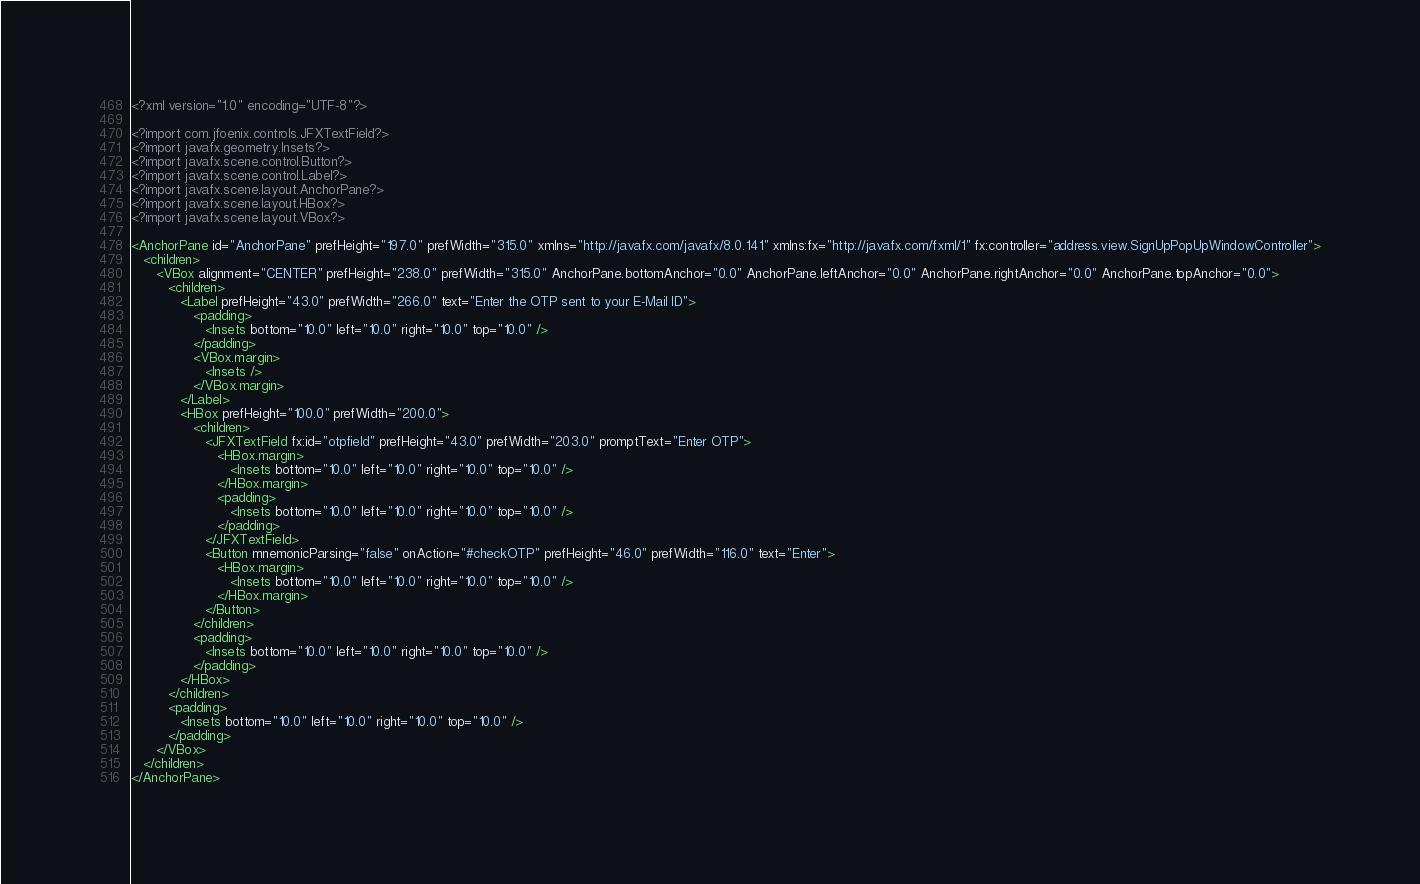Convert code to text. <code><loc_0><loc_0><loc_500><loc_500><_XML_><?xml version="1.0" encoding="UTF-8"?>

<?import com.jfoenix.controls.JFXTextField?>
<?import javafx.geometry.Insets?>
<?import javafx.scene.control.Button?>
<?import javafx.scene.control.Label?>
<?import javafx.scene.layout.AnchorPane?>
<?import javafx.scene.layout.HBox?>
<?import javafx.scene.layout.VBox?>

<AnchorPane id="AnchorPane" prefHeight="197.0" prefWidth="315.0" xmlns="http://javafx.com/javafx/8.0.141" xmlns:fx="http://javafx.com/fxml/1" fx:controller="address.view.SignUpPopUpWindowController">
   <children>
      <VBox alignment="CENTER" prefHeight="238.0" prefWidth="315.0" AnchorPane.bottomAnchor="0.0" AnchorPane.leftAnchor="0.0" AnchorPane.rightAnchor="0.0" AnchorPane.topAnchor="0.0">
         <children>
            <Label prefHeight="43.0" prefWidth="266.0" text="Enter the OTP sent to your E-Mail ID">
               <padding>
                  <Insets bottom="10.0" left="10.0" right="10.0" top="10.0" />
               </padding>
               <VBox.margin>
                  <Insets />
               </VBox.margin>
            </Label>
            <HBox prefHeight="100.0" prefWidth="200.0">
               <children>
                  <JFXTextField fx:id="otpfield" prefHeight="43.0" prefWidth="203.0" promptText="Enter OTP">
                     <HBox.margin>
                        <Insets bottom="10.0" left="10.0" right="10.0" top="10.0" />
                     </HBox.margin>
                     <padding>
                        <Insets bottom="10.0" left="10.0" right="10.0" top="10.0" />
                     </padding>
                  </JFXTextField>
                  <Button mnemonicParsing="false" onAction="#checkOTP" prefHeight="46.0" prefWidth="116.0" text="Enter">
                     <HBox.margin>
                        <Insets bottom="10.0" left="10.0" right="10.0" top="10.0" />
                     </HBox.margin>
                  </Button>
               </children>
               <padding>
                  <Insets bottom="10.0" left="10.0" right="10.0" top="10.0" />
               </padding>
            </HBox>
         </children>
         <padding>
            <Insets bottom="10.0" left="10.0" right="10.0" top="10.0" />
         </padding>
      </VBox>
   </children>
</AnchorPane>
</code> 